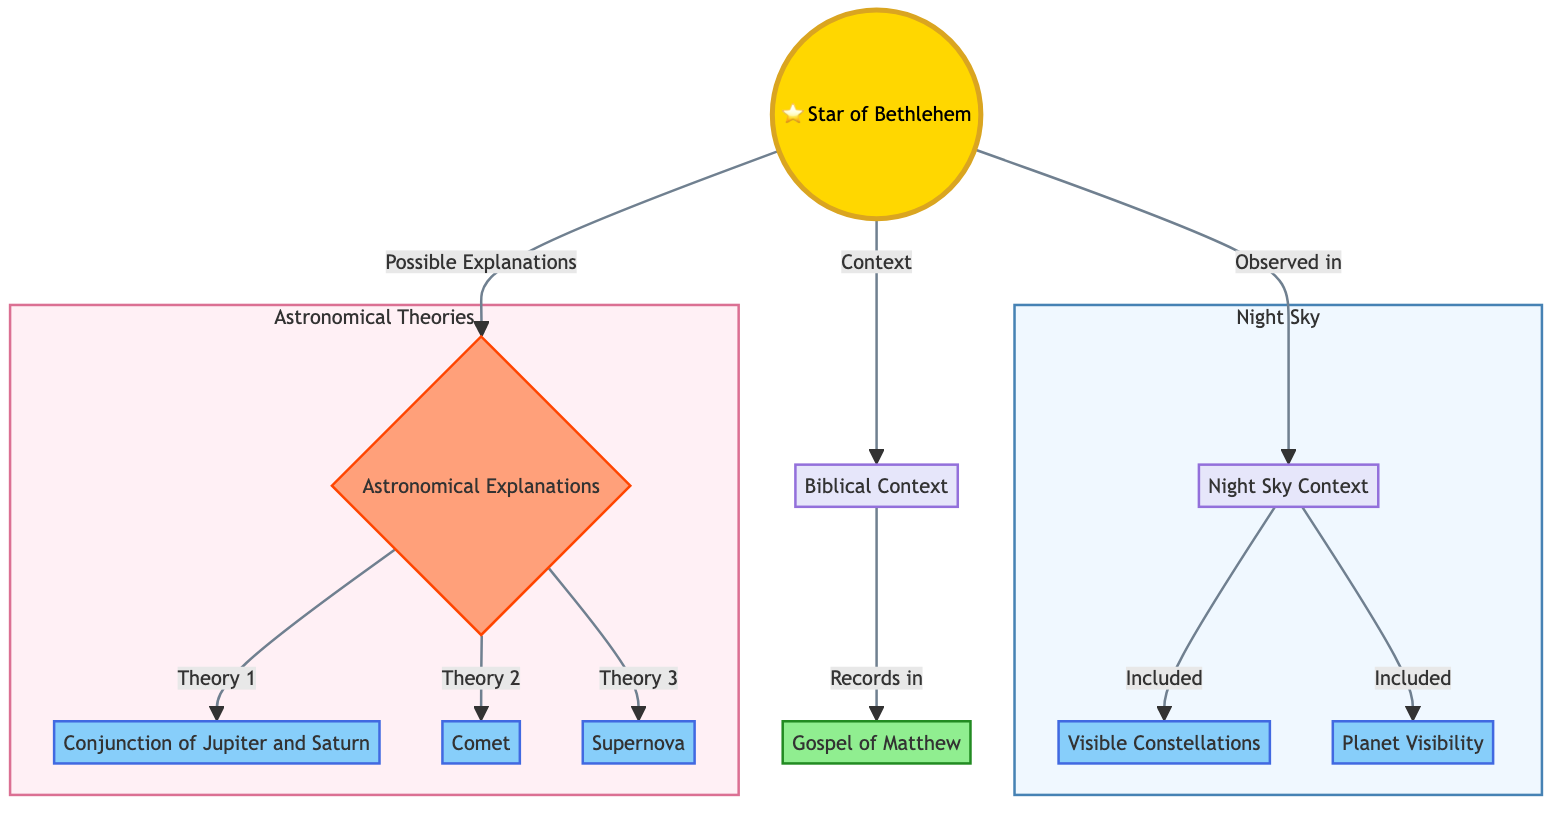What does the Star of Bethlehem lead to in the diagram? The Star of Bethlehem is connected to two main nodes: Biblical Context and Astronomical Explanations. This indicates that it serves as a central point that connects these two areas of knowledge.
Answer: Biblical Context, Astronomical Explanations How many astronomical theories are listed in the diagram? The diagram shows three different theories regarding the astronomical explanations of the Star of Bethlehem: Conjunction of Jupiter and Saturn, Comet, and Supernova. Therefore, we can count these nodes to arrive at the answer.
Answer: 3 Which Gospel records the biblical context? The diagram indicates that the specific Gospel recording the biblical context is the Gospel of Matthew, as it is directly connected to the Biblical Context node.
Answer: Gospel of Matthew What does the Night Sky Context include? The Night Sky Context includes two components: Visible Constellations and Planet Visibility, both of which are connected under the Night Sky Context node, making them part of this category.
Answer: Visible Constellations, Planet Visibility What is the relationship between the Star of Bethlehem and the Night Sky Context? The diagram shows that the Star of Bethlehem is observed in the Night Sky Context, indicating that there is a direct relationship in terms of visibility and celestial occurrences.
Answer: Observed in Explain the significance of the astronomical explanations provided in the diagram. The astronomical explanations help to theorize potential natural occurrences that could be identified or interpreted as the Star of Bethlehem. Each theory suggests a different celestial event, such as the conjunction of planets, a comet’s appearance, or a supernova explosion. Thus, these explanations provide a scientific basis for understanding the Star's significance.
Answer: Astronomical Theories Which nodes are grouped under "Night Sky"? The nodes grouped under "Night Sky" are Night Sky Context, Visible Constellations, and Planet Visibility. By reviewing the subgraph labeled "Sky," we see these nodes included there, indicating they are part of the overall category of night sky observation.
Answer: Night Sky Context, Visible Constellations, Planet Visibility What type of celestial event is indicated as Theory 1? According to the diagram, Theory 1 under the Astronomical Explanations states that the Conjunction of Jupiter and Saturn could be a potential explanation for the Star of Bethlehem, highlighting this specific alignment as a significant celestial event.
Answer: Conjunction of Jupiter and Saturn 